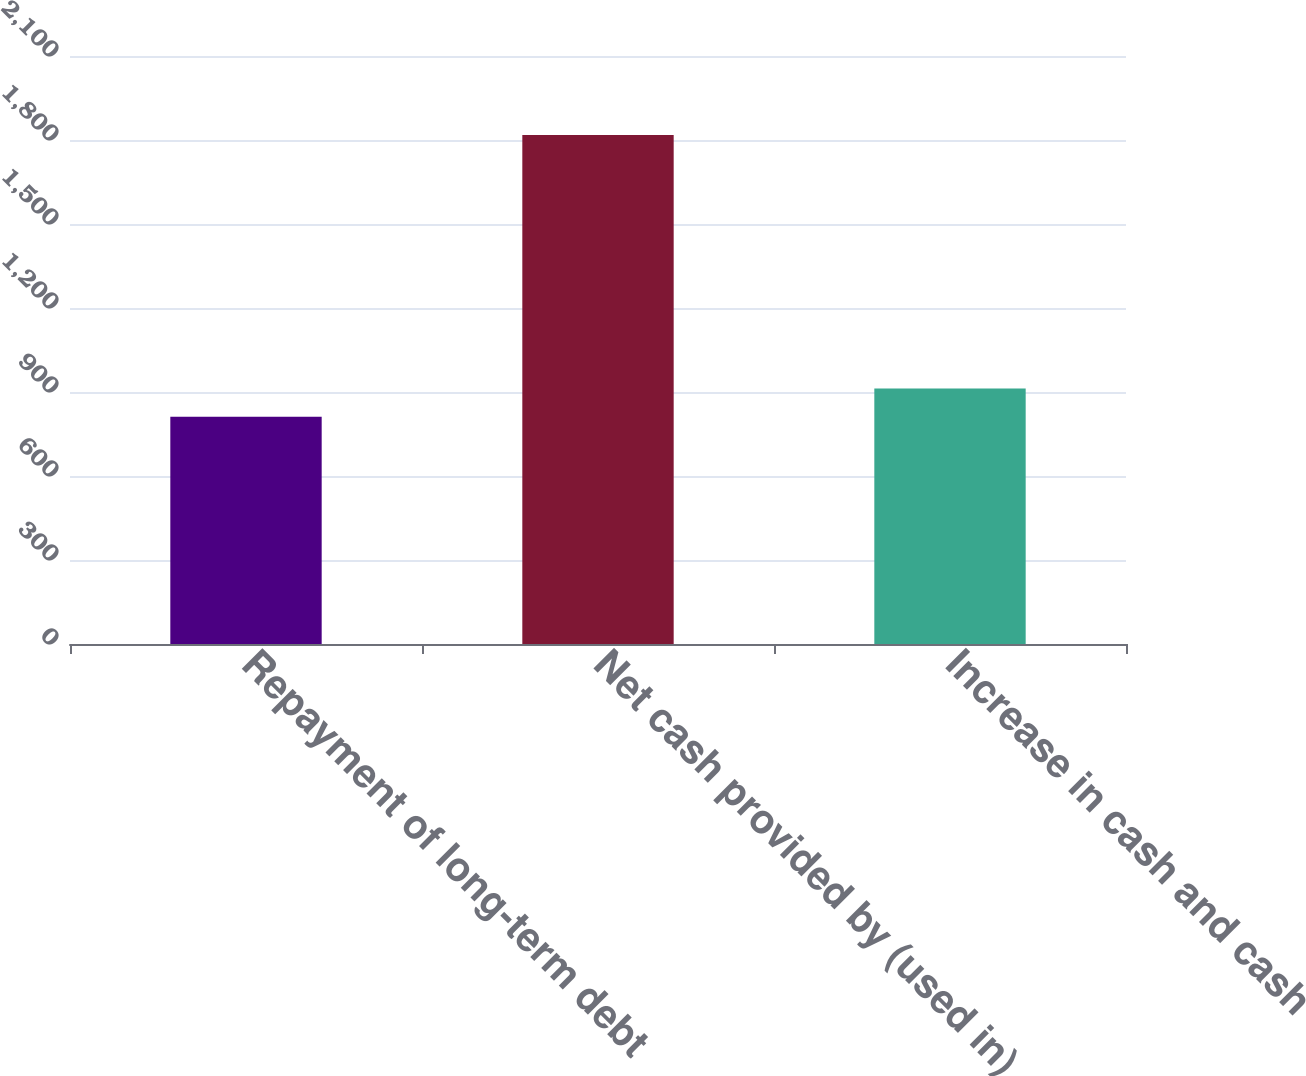Convert chart. <chart><loc_0><loc_0><loc_500><loc_500><bar_chart><fcel>Repayment of long-term debt<fcel>Net cash provided by (used in)<fcel>Increase in cash and cash<nl><fcel>812<fcel>1818<fcel>912.6<nl></chart> 